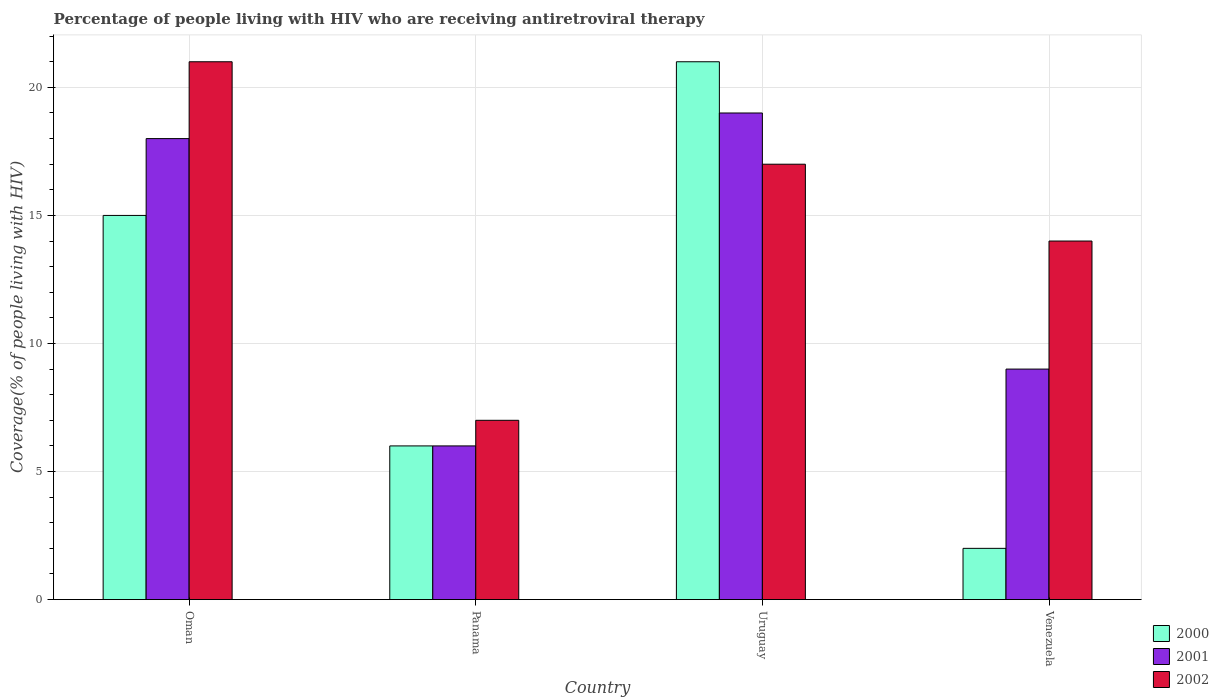How many bars are there on the 2nd tick from the left?
Make the answer very short. 3. What is the label of the 2nd group of bars from the left?
Give a very brief answer. Panama. In how many cases, is the number of bars for a given country not equal to the number of legend labels?
Ensure brevity in your answer.  0. What is the percentage of the HIV infected people who are receiving antiretroviral therapy in 2000 in Oman?
Make the answer very short. 15. In which country was the percentage of the HIV infected people who are receiving antiretroviral therapy in 2000 maximum?
Ensure brevity in your answer.  Uruguay. In which country was the percentage of the HIV infected people who are receiving antiretroviral therapy in 2002 minimum?
Ensure brevity in your answer.  Panama. What is the total percentage of the HIV infected people who are receiving antiretroviral therapy in 2002 in the graph?
Your answer should be very brief. 59. What is the difference between the percentage of the HIV infected people who are receiving antiretroviral therapy in 2000 in Oman and that in Panama?
Your answer should be compact. 9. What is the difference between the percentage of the HIV infected people who are receiving antiretroviral therapy of/in 2002 and percentage of the HIV infected people who are receiving antiretroviral therapy of/in 2000 in Venezuela?
Give a very brief answer. 12. In how many countries, is the percentage of the HIV infected people who are receiving antiretroviral therapy in 2002 greater than 17 %?
Your response must be concise. 1. What is the ratio of the percentage of the HIV infected people who are receiving antiretroviral therapy in 2000 in Oman to that in Uruguay?
Your response must be concise. 0.71. Is the percentage of the HIV infected people who are receiving antiretroviral therapy in 2002 in Oman less than that in Venezuela?
Your response must be concise. No. What does the 3rd bar from the right in Oman represents?
Provide a succinct answer. 2000. Is it the case that in every country, the sum of the percentage of the HIV infected people who are receiving antiretroviral therapy in 2000 and percentage of the HIV infected people who are receiving antiretroviral therapy in 2001 is greater than the percentage of the HIV infected people who are receiving antiretroviral therapy in 2002?
Ensure brevity in your answer.  No. How many bars are there?
Your answer should be compact. 12. How many countries are there in the graph?
Provide a short and direct response. 4. What is the difference between two consecutive major ticks on the Y-axis?
Keep it short and to the point. 5. Does the graph contain any zero values?
Offer a very short reply. No. Does the graph contain grids?
Ensure brevity in your answer.  Yes. Where does the legend appear in the graph?
Keep it short and to the point. Bottom right. How many legend labels are there?
Your response must be concise. 3. How are the legend labels stacked?
Provide a succinct answer. Vertical. What is the title of the graph?
Your answer should be very brief. Percentage of people living with HIV who are receiving antiretroviral therapy. Does "1984" appear as one of the legend labels in the graph?
Offer a very short reply. No. What is the label or title of the Y-axis?
Offer a very short reply. Coverage(% of people living with HIV). What is the Coverage(% of people living with HIV) of 2000 in Oman?
Keep it short and to the point. 15. What is the Coverage(% of people living with HIV) of 2000 in Panama?
Provide a succinct answer. 6. What is the Coverage(% of people living with HIV) in 2001 in Panama?
Give a very brief answer. 6. What is the Coverage(% of people living with HIV) in 2000 in Uruguay?
Provide a succinct answer. 21. What is the Coverage(% of people living with HIV) in 2001 in Uruguay?
Keep it short and to the point. 19. What is the Coverage(% of people living with HIV) of 2002 in Uruguay?
Offer a very short reply. 17. What is the Coverage(% of people living with HIV) of 2000 in Venezuela?
Your answer should be very brief. 2. What is the Coverage(% of people living with HIV) of 2001 in Venezuela?
Ensure brevity in your answer.  9. What is the Coverage(% of people living with HIV) of 2002 in Venezuela?
Ensure brevity in your answer.  14. Across all countries, what is the maximum Coverage(% of people living with HIV) of 2002?
Your answer should be very brief. 21. Across all countries, what is the minimum Coverage(% of people living with HIV) in 2000?
Provide a short and direct response. 2. Across all countries, what is the minimum Coverage(% of people living with HIV) of 2001?
Your response must be concise. 6. What is the difference between the Coverage(% of people living with HIV) of 2001 in Oman and that in Panama?
Ensure brevity in your answer.  12. What is the difference between the Coverage(% of people living with HIV) in 2000 in Oman and that in Venezuela?
Your answer should be compact. 13. What is the difference between the Coverage(% of people living with HIV) of 2001 in Oman and that in Venezuela?
Provide a succinct answer. 9. What is the difference between the Coverage(% of people living with HIV) in 2002 in Oman and that in Venezuela?
Offer a terse response. 7. What is the difference between the Coverage(% of people living with HIV) of 2000 in Panama and that in Uruguay?
Provide a short and direct response. -15. What is the difference between the Coverage(% of people living with HIV) in 2001 in Panama and that in Uruguay?
Ensure brevity in your answer.  -13. What is the difference between the Coverage(% of people living with HIV) in 2000 in Panama and that in Venezuela?
Give a very brief answer. 4. What is the difference between the Coverage(% of people living with HIV) of 2001 in Panama and that in Venezuela?
Offer a very short reply. -3. What is the difference between the Coverage(% of people living with HIV) of 2002 in Panama and that in Venezuela?
Keep it short and to the point. -7. What is the difference between the Coverage(% of people living with HIV) of 2000 in Uruguay and that in Venezuela?
Keep it short and to the point. 19. What is the difference between the Coverage(% of people living with HIV) in 2001 in Uruguay and that in Venezuela?
Make the answer very short. 10. What is the difference between the Coverage(% of people living with HIV) in 2001 in Oman and the Coverage(% of people living with HIV) in 2002 in Venezuela?
Keep it short and to the point. 4. What is the difference between the Coverage(% of people living with HIV) in 2000 in Panama and the Coverage(% of people living with HIV) in 2002 in Uruguay?
Offer a very short reply. -11. What is the difference between the Coverage(% of people living with HIV) of 2000 in Uruguay and the Coverage(% of people living with HIV) of 2001 in Venezuela?
Ensure brevity in your answer.  12. What is the difference between the Coverage(% of people living with HIV) in 2001 in Uruguay and the Coverage(% of people living with HIV) in 2002 in Venezuela?
Provide a short and direct response. 5. What is the average Coverage(% of people living with HIV) in 2000 per country?
Keep it short and to the point. 11. What is the average Coverage(% of people living with HIV) in 2002 per country?
Offer a very short reply. 14.75. What is the difference between the Coverage(% of people living with HIV) of 2000 and Coverage(% of people living with HIV) of 2002 in Oman?
Your response must be concise. -6. What is the difference between the Coverage(% of people living with HIV) in 2001 and Coverage(% of people living with HIV) in 2002 in Oman?
Give a very brief answer. -3. What is the difference between the Coverage(% of people living with HIV) of 2000 and Coverage(% of people living with HIV) of 2002 in Panama?
Offer a very short reply. -1. What is the difference between the Coverage(% of people living with HIV) in 2001 and Coverage(% of people living with HIV) in 2002 in Panama?
Provide a short and direct response. -1. What is the difference between the Coverage(% of people living with HIV) in 2000 and Coverage(% of people living with HIV) in 2001 in Uruguay?
Your answer should be compact. 2. What is the difference between the Coverage(% of people living with HIV) of 2000 and Coverage(% of people living with HIV) of 2002 in Uruguay?
Ensure brevity in your answer.  4. What is the difference between the Coverage(% of people living with HIV) of 2001 and Coverage(% of people living with HIV) of 2002 in Uruguay?
Make the answer very short. 2. What is the difference between the Coverage(% of people living with HIV) of 2000 and Coverage(% of people living with HIV) of 2001 in Venezuela?
Provide a succinct answer. -7. What is the difference between the Coverage(% of people living with HIV) in 2000 and Coverage(% of people living with HIV) in 2002 in Venezuela?
Your response must be concise. -12. What is the ratio of the Coverage(% of people living with HIV) in 2000 in Oman to that in Panama?
Provide a short and direct response. 2.5. What is the ratio of the Coverage(% of people living with HIV) of 2001 in Oman to that in Panama?
Provide a succinct answer. 3. What is the ratio of the Coverage(% of people living with HIV) in 2000 in Oman to that in Uruguay?
Your response must be concise. 0.71. What is the ratio of the Coverage(% of people living with HIV) in 2002 in Oman to that in Uruguay?
Your answer should be compact. 1.24. What is the ratio of the Coverage(% of people living with HIV) in 2000 in Oman to that in Venezuela?
Make the answer very short. 7.5. What is the ratio of the Coverage(% of people living with HIV) of 2001 in Oman to that in Venezuela?
Keep it short and to the point. 2. What is the ratio of the Coverage(% of people living with HIV) in 2000 in Panama to that in Uruguay?
Keep it short and to the point. 0.29. What is the ratio of the Coverage(% of people living with HIV) of 2001 in Panama to that in Uruguay?
Give a very brief answer. 0.32. What is the ratio of the Coverage(% of people living with HIV) of 2002 in Panama to that in Uruguay?
Provide a succinct answer. 0.41. What is the ratio of the Coverage(% of people living with HIV) in 2001 in Panama to that in Venezuela?
Keep it short and to the point. 0.67. What is the ratio of the Coverage(% of people living with HIV) of 2001 in Uruguay to that in Venezuela?
Your answer should be compact. 2.11. What is the ratio of the Coverage(% of people living with HIV) in 2002 in Uruguay to that in Venezuela?
Ensure brevity in your answer.  1.21. What is the difference between the highest and the second highest Coverage(% of people living with HIV) of 2000?
Provide a short and direct response. 6. What is the difference between the highest and the lowest Coverage(% of people living with HIV) of 2000?
Offer a very short reply. 19. What is the difference between the highest and the lowest Coverage(% of people living with HIV) in 2001?
Your response must be concise. 13. 